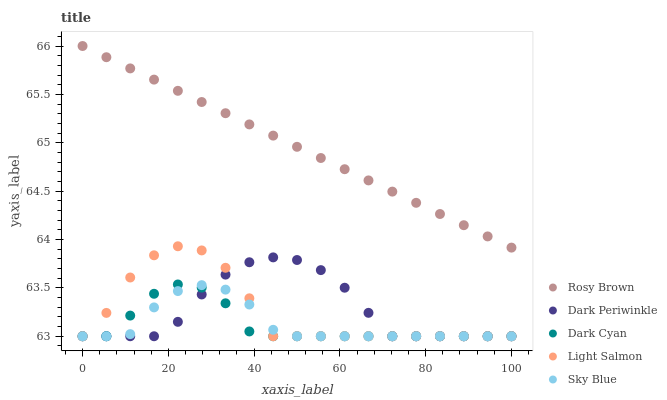Does Dark Cyan have the minimum area under the curve?
Answer yes or no. Yes. Does Rosy Brown have the maximum area under the curve?
Answer yes or no. Yes. Does Sky Blue have the minimum area under the curve?
Answer yes or no. No. Does Sky Blue have the maximum area under the curve?
Answer yes or no. No. Is Rosy Brown the smoothest?
Answer yes or no. Yes. Is Light Salmon the roughest?
Answer yes or no. Yes. Is Sky Blue the smoothest?
Answer yes or no. No. Is Sky Blue the roughest?
Answer yes or no. No. Does Dark Cyan have the lowest value?
Answer yes or no. Yes. Does Rosy Brown have the lowest value?
Answer yes or no. No. Does Rosy Brown have the highest value?
Answer yes or no. Yes. Does Light Salmon have the highest value?
Answer yes or no. No. Is Sky Blue less than Rosy Brown?
Answer yes or no. Yes. Is Rosy Brown greater than Sky Blue?
Answer yes or no. Yes. Does Light Salmon intersect Dark Periwinkle?
Answer yes or no. Yes. Is Light Salmon less than Dark Periwinkle?
Answer yes or no. No. Is Light Salmon greater than Dark Periwinkle?
Answer yes or no. No. Does Sky Blue intersect Rosy Brown?
Answer yes or no. No. 